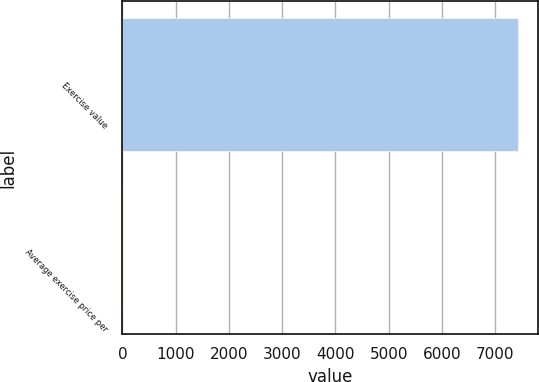Convert chart. <chart><loc_0><loc_0><loc_500><loc_500><bar_chart><fcel>Exercise value<fcel>Average exercise price per<nl><fcel>7428<fcel>18.07<nl></chart> 